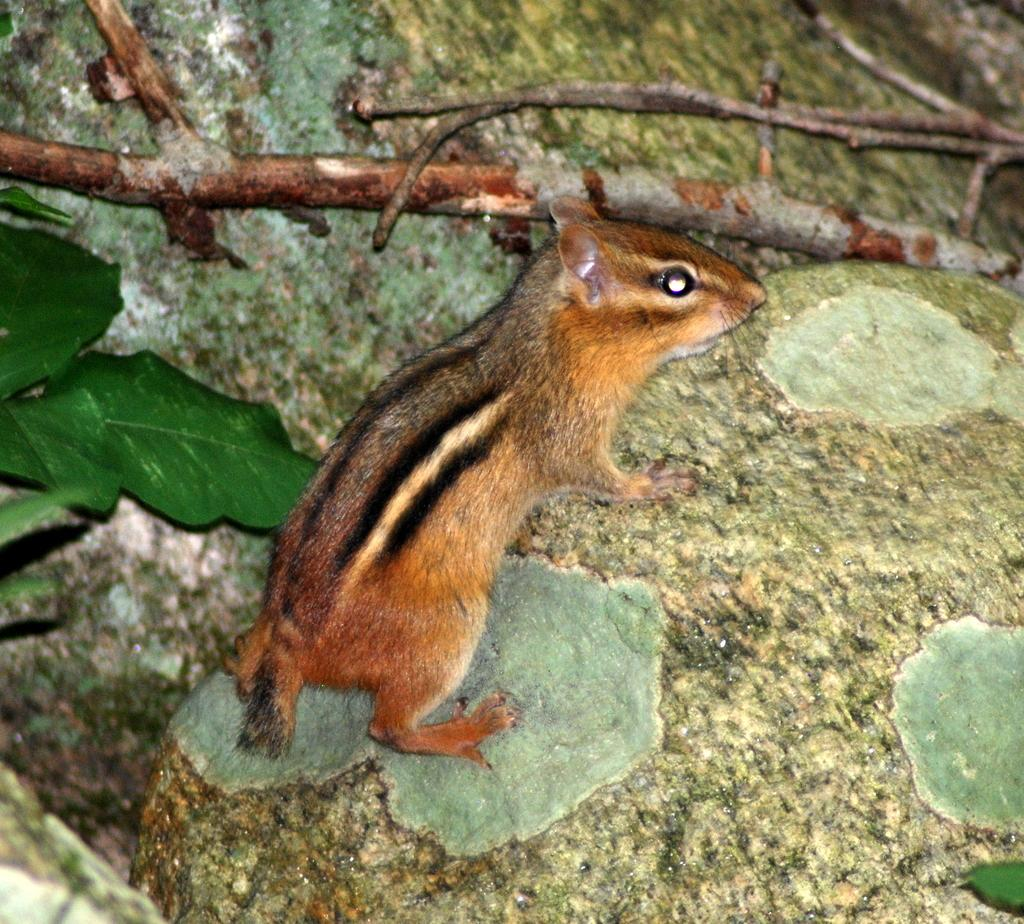What type of animal can be seen in the image? There is a brown squirrel in the image. What objects are present in the image besides the squirrel? There are sticks and green leaves visible in the image. What type of pie is the squirrel holding in the image? There is no pie present in the image; the squirrel is not holding anything. 